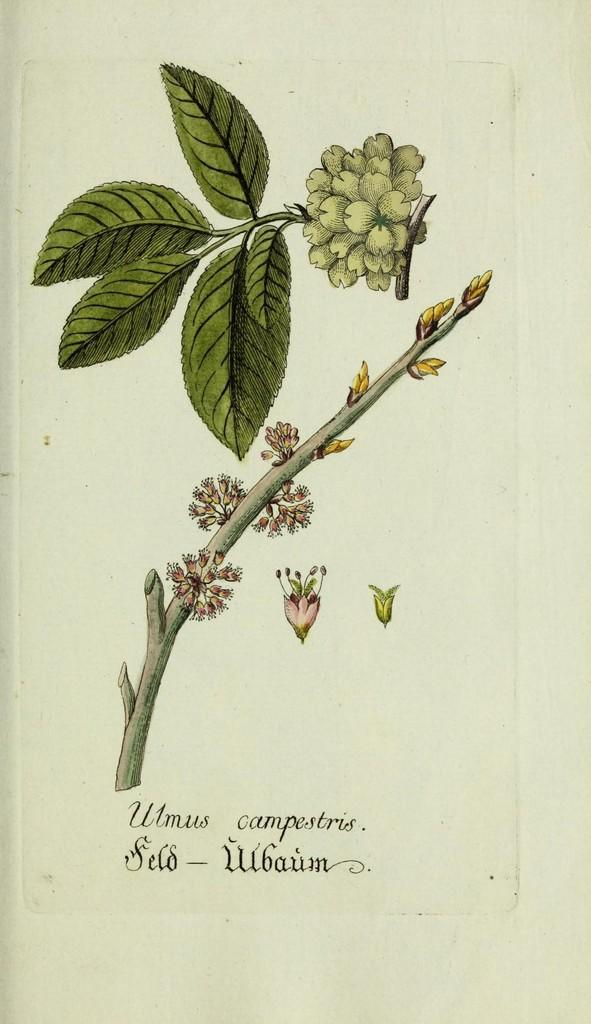What is the main subject of the image? The main subject of the image is a stem with flowers. What colors are the flowers in the image? The flowers are in pink and yellow colors. What else can be seen in the image besides the flowers? There are leaves in the image. Is there any text or label in the image? Yes, there is a name at the bottom of the image below the stem. What type of voice can be heard coming from the flowers in the image? There is no voice present in the image, as flowers do not have the ability to produce sound. 